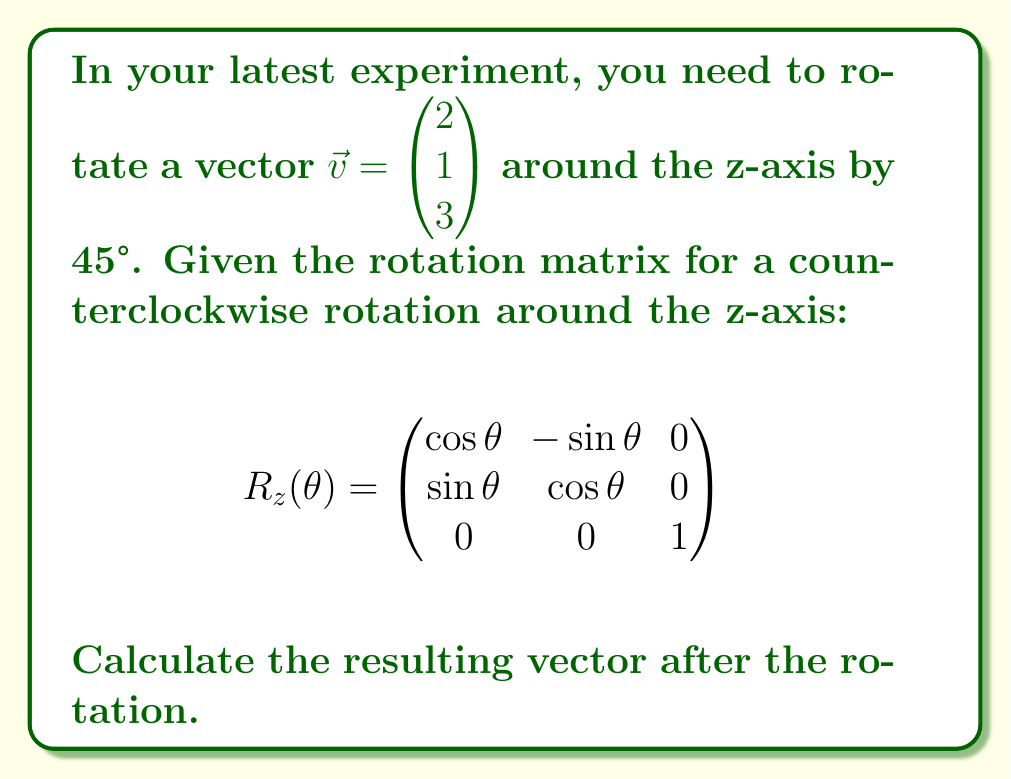Teach me how to tackle this problem. To solve this problem, we'll follow these steps:

1) First, we need to recall the formula for rotating a vector $\vec{v}$ using a rotation matrix $R$:

   $\vec{v}_{rotated} = R \cdot \vec{v}$

2) We're given that $\theta = 45°$. Let's calculate $\cos(45°)$ and $\sin(45°)$:
   
   $\cos(45°) = \sin(45°) = \frac{1}{\sqrt{2}} \approx 0.7071$

3) Now, let's substitute these values into our rotation matrix:

   $$R_z(45°) = \begin{pmatrix}
   0.7071 & -0.7071 & 0 \\
   0.7071 & 0.7071 & 0 \\
   0 & 0 & 1
   \end{pmatrix}$$

4) Next, we'll multiply this matrix by our vector:

   $$\begin{pmatrix}
   0.7071 & -0.7071 & 0 \\
   0.7071 & 0.7071 & 0 \\
   0 & 0 & 1
   \end{pmatrix} \cdot \begin{pmatrix} 2 \\ 1 \\ 3 \end{pmatrix}$$

5) Performing the matrix multiplication:

   $$(0.7071 \cdot 2 + (-0.7071) \cdot 1 + 0 \cdot 3) \hat{i} +
   (0.7071 \cdot 2 + 0.7071 \cdot 1 + 0 \cdot 3) \hat{j} +
   (0 \cdot 2 + 0 \cdot 1 + 1 \cdot 3) \hat{k}$$

6) Simplifying:

   $$(1.4142 - 0.7071) \hat{i} + (1.4142 + 0.7071) \hat{j} + 3 \hat{k}$$

7) Calculating the final values:

   $$0.7071 \hat{i} + 2.1213 \hat{j} + 3 \hat{k}$$
Answer: $\begin{pmatrix} 0.7071 \\ 2.1213 \\ 3 \end{pmatrix}$ 